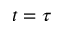<formula> <loc_0><loc_0><loc_500><loc_500>t = \tau</formula> 